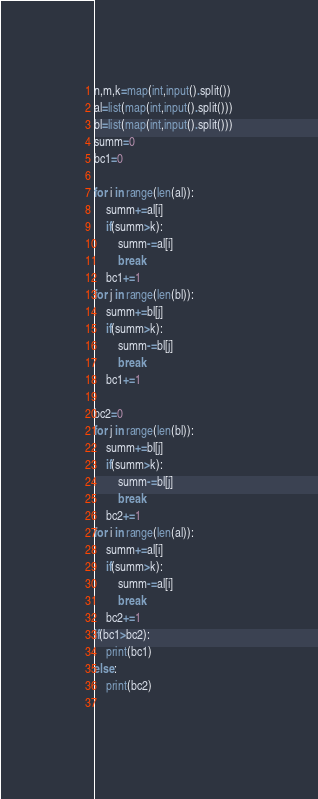<code> <loc_0><loc_0><loc_500><loc_500><_Python_>n,m,k=map(int,input().split())
al=list(map(int,input().split()))
bl=list(map(int,input().split()))
summ=0
bc1=0

for i in range(len(al)):
    summ+=al[i]
    if(summ>k):
        summ-=al[i]
        break
    bc1+=1
for j in range(len(bl)):
    summ+=bl[j]
    if(summ>k):
        summ-=bl[j]
        break
    bc1+=1

bc2=0
for j in range(len(bl)):
    summ+=bl[j]
    if(summ>k):
        summ-=bl[j]
        break
    bc2+=1
for i in range(len(al)):
    summ+=al[i]
    if(summ>k):
        summ-=al[i]
        break
    bc2+=1    
if(bc1>bc2):
    print(bc1)
else:
    print(bc2)
        </code> 